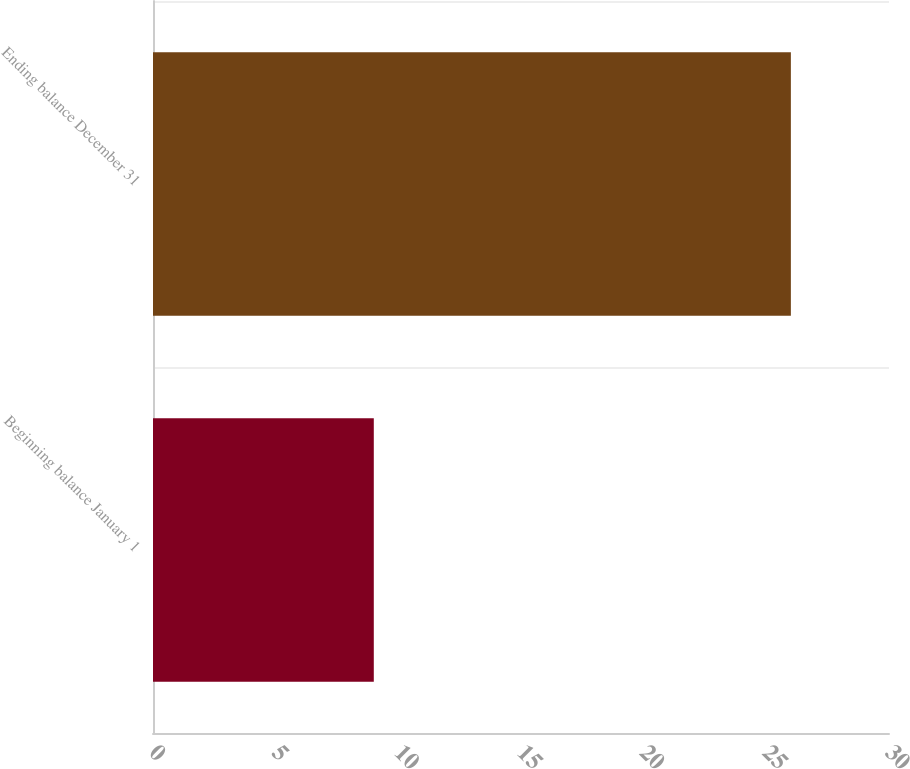Convert chart to OTSL. <chart><loc_0><loc_0><loc_500><loc_500><bar_chart><fcel>Beginning balance January 1<fcel>Ending balance December 31<nl><fcel>9<fcel>26<nl></chart> 